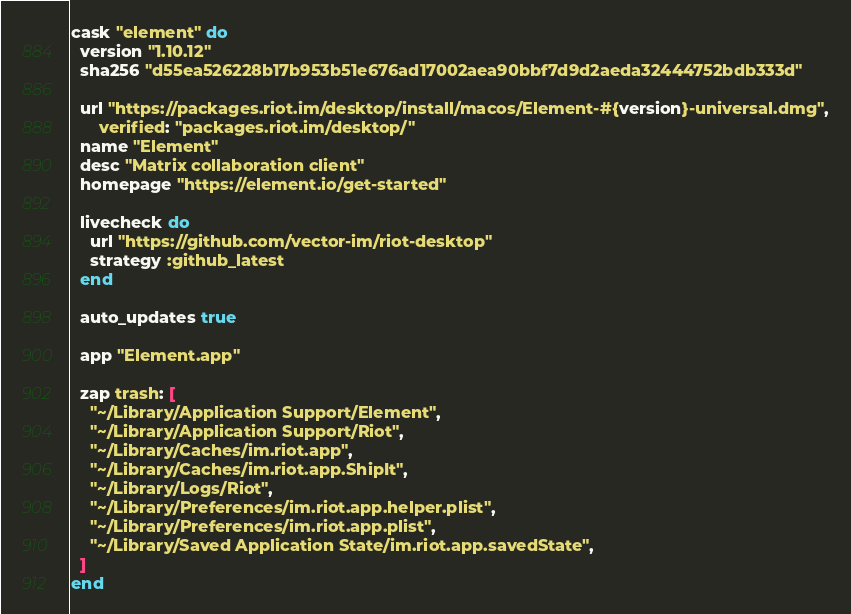Convert code to text. <code><loc_0><loc_0><loc_500><loc_500><_Ruby_>cask "element" do
  version "1.10.12"
  sha256 "d55ea526228b17b953b51e676ad17002aea90bbf7d9d2aeda32444752bdb333d"

  url "https://packages.riot.im/desktop/install/macos/Element-#{version}-universal.dmg",
      verified: "packages.riot.im/desktop/"
  name "Element"
  desc "Matrix collaboration client"
  homepage "https://element.io/get-started"

  livecheck do
    url "https://github.com/vector-im/riot-desktop"
    strategy :github_latest
  end

  auto_updates true

  app "Element.app"

  zap trash: [
    "~/Library/Application Support/Element",
    "~/Library/Application Support/Riot",
    "~/Library/Caches/im.riot.app",
    "~/Library/Caches/im.riot.app.ShipIt",
    "~/Library/Logs/Riot",
    "~/Library/Preferences/im.riot.app.helper.plist",
    "~/Library/Preferences/im.riot.app.plist",
    "~/Library/Saved Application State/im.riot.app.savedState",
  ]
end
</code> 